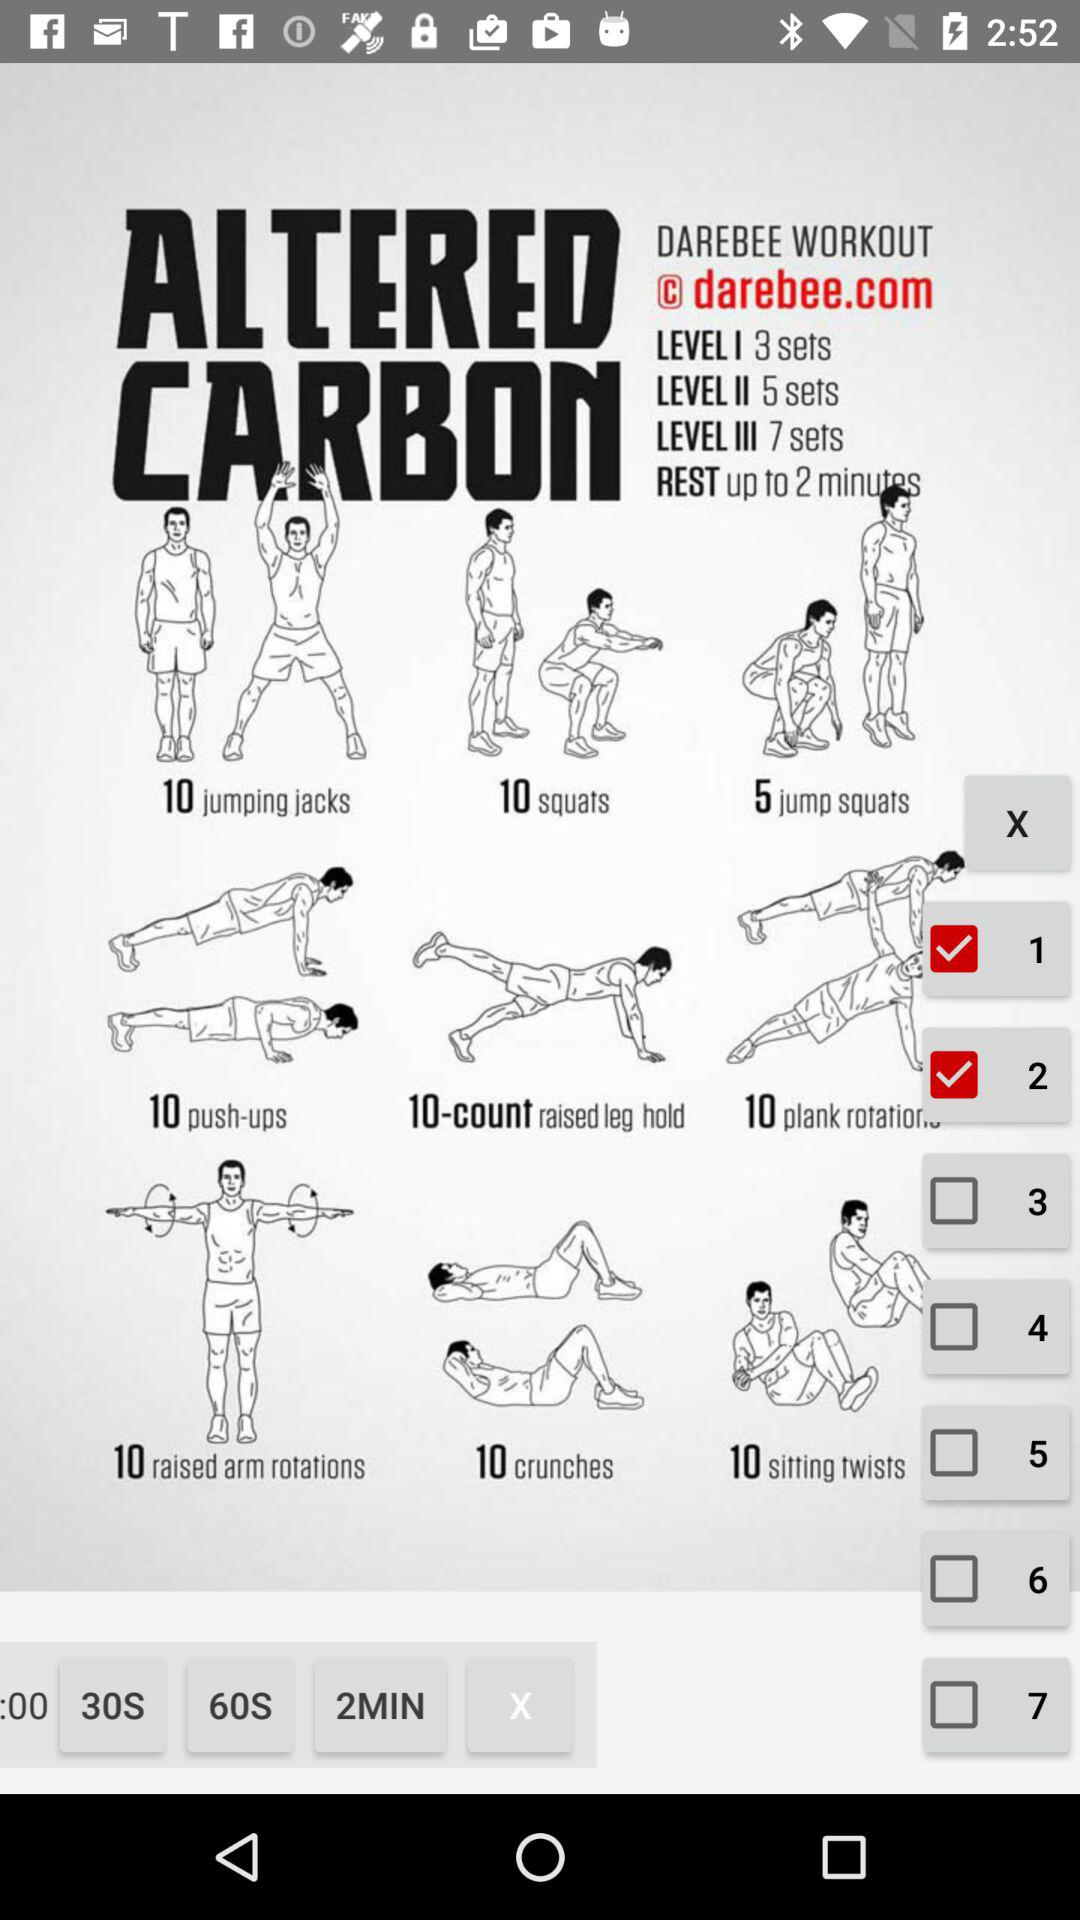Which option is checked? The checked options are "1" and "2". 